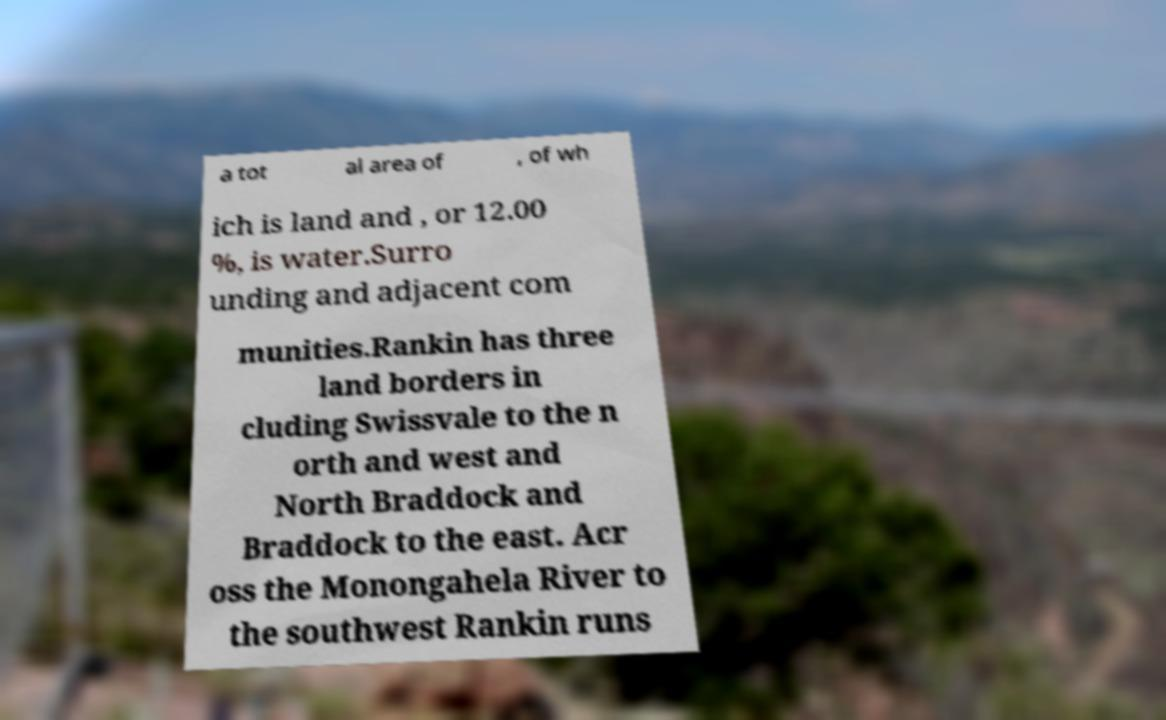Please identify and transcribe the text found in this image. a tot al area of , of wh ich is land and , or 12.00 %, is water.Surro unding and adjacent com munities.Rankin has three land borders in cluding Swissvale to the n orth and west and North Braddock and Braddock to the east. Acr oss the Monongahela River to the southwest Rankin runs 